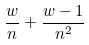<formula> <loc_0><loc_0><loc_500><loc_500>\frac { w } { n } + \frac { w - 1 } { n ^ { 2 } }</formula> 